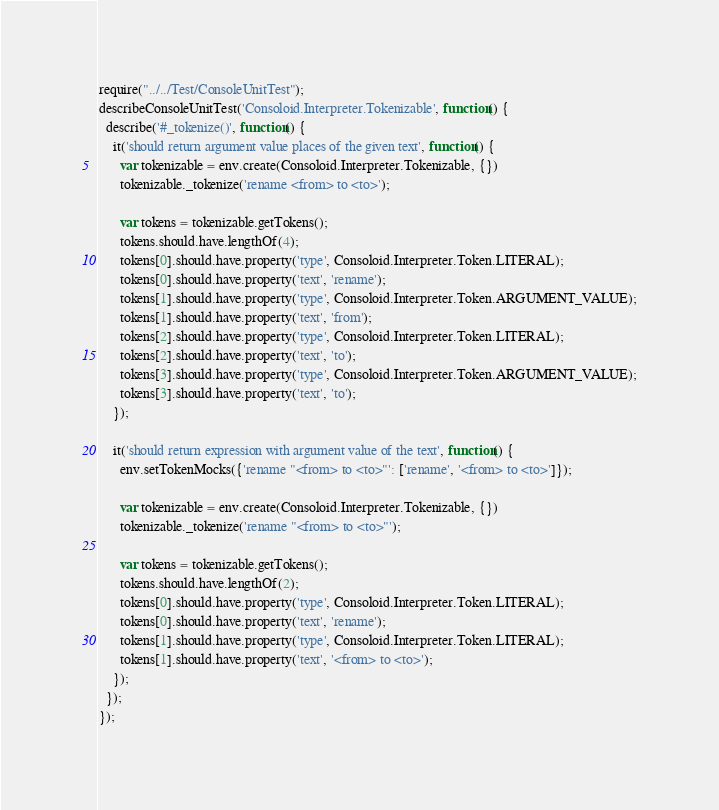<code> <loc_0><loc_0><loc_500><loc_500><_JavaScript_>require("../../Test/ConsoleUnitTest");
describeConsoleUnitTest('Consoloid.Interpreter.Tokenizable', function() {
  describe('#_tokenize()', function() {
    it('should return argument value places of the given text', function() {
      var tokenizable = env.create(Consoloid.Interpreter.Tokenizable, {})
      tokenizable._tokenize('rename <from> to <to>');

      var tokens = tokenizable.getTokens();
      tokens.should.have.lengthOf(4);
      tokens[0].should.have.property('type', Consoloid.Interpreter.Token.LITERAL);
      tokens[0].should.have.property('text', 'rename');
      tokens[1].should.have.property('type', Consoloid.Interpreter.Token.ARGUMENT_VALUE);
      tokens[1].should.have.property('text', 'from');
      tokens[2].should.have.property('type', Consoloid.Interpreter.Token.LITERAL);
      tokens[2].should.have.property('text', 'to');
      tokens[3].should.have.property('type', Consoloid.Interpreter.Token.ARGUMENT_VALUE);
      tokens[3].should.have.property('text', 'to');
    });

    it('should return expression with argument value of the text', function() {
      env.setTokenMocks({'rename "<from> to <to>"': ['rename', '<from> to <to>']});

      var tokenizable = env.create(Consoloid.Interpreter.Tokenizable, {})
      tokenizable._tokenize('rename "<from> to <to>"');

      var tokens = tokenizable.getTokens();
      tokens.should.have.lengthOf(2);
      tokens[0].should.have.property('type', Consoloid.Interpreter.Token.LITERAL);
      tokens[0].should.have.property('text', 'rename');
      tokens[1].should.have.property('type', Consoloid.Interpreter.Token.LITERAL);
      tokens[1].should.have.property('text', '<from> to <to>');
    });
  });
});
</code> 